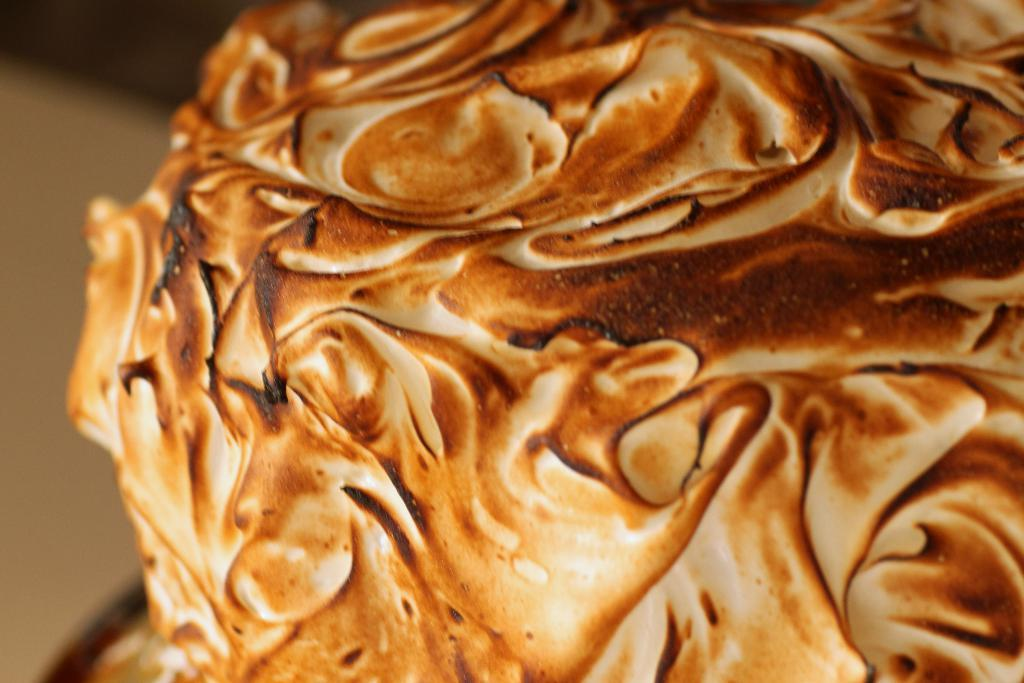What dessert is featured in the image? The image contains baked Alaska. Can you describe the background of the image? The background of the image is blurred. Are there any fairies visible in the image? There are no fairies present in the image. What type of knowledge can be gained from the image? The image does not convey any specific knowledge or information beyond the presence of baked Alaska and the blurred background. 